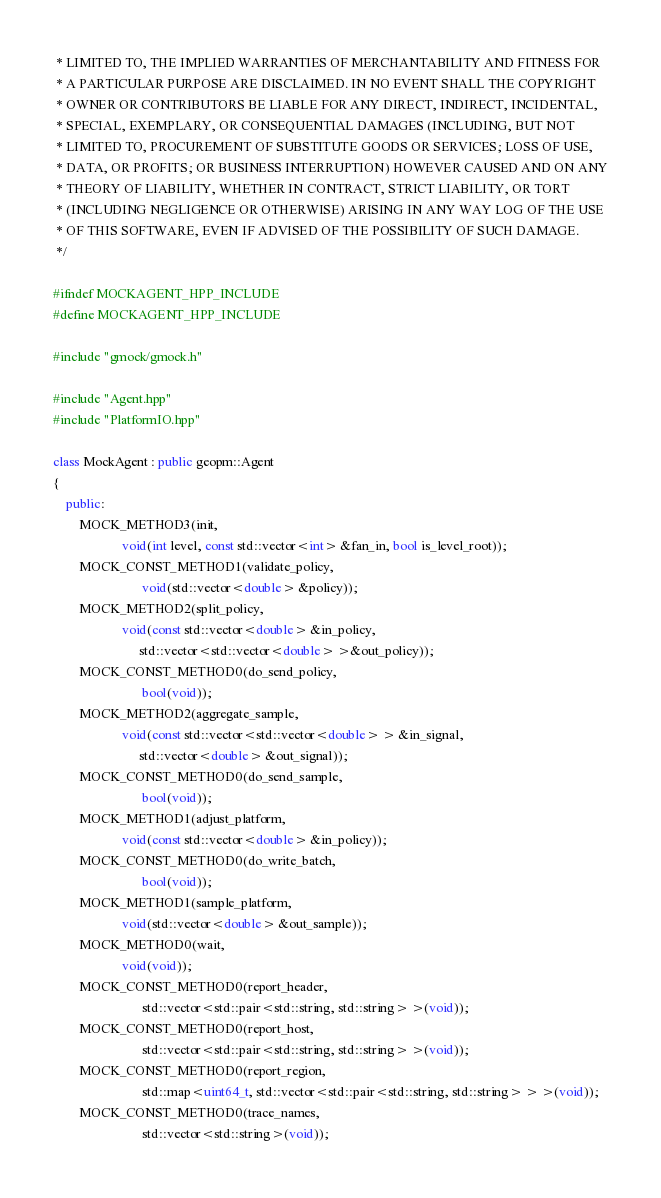Convert code to text. <code><loc_0><loc_0><loc_500><loc_500><_C++_> * LIMITED TO, THE IMPLIED WARRANTIES OF MERCHANTABILITY AND FITNESS FOR
 * A PARTICULAR PURPOSE ARE DISCLAIMED. IN NO EVENT SHALL THE COPYRIGHT
 * OWNER OR CONTRIBUTORS BE LIABLE FOR ANY DIRECT, INDIRECT, INCIDENTAL,
 * SPECIAL, EXEMPLARY, OR CONSEQUENTIAL DAMAGES (INCLUDING, BUT NOT
 * LIMITED TO, PROCUREMENT OF SUBSTITUTE GOODS OR SERVICES; LOSS OF USE,
 * DATA, OR PROFITS; OR BUSINESS INTERRUPTION) HOWEVER CAUSED AND ON ANY
 * THEORY OF LIABILITY, WHETHER IN CONTRACT, STRICT LIABILITY, OR TORT
 * (INCLUDING NEGLIGENCE OR OTHERWISE) ARISING IN ANY WAY LOG OF THE USE
 * OF THIS SOFTWARE, EVEN IF ADVISED OF THE POSSIBILITY OF SUCH DAMAGE.
 */

#ifndef MOCKAGENT_HPP_INCLUDE
#define MOCKAGENT_HPP_INCLUDE

#include "gmock/gmock.h"

#include "Agent.hpp"
#include "PlatformIO.hpp"

class MockAgent : public geopm::Agent
{
    public:
        MOCK_METHOD3(init,
                     void(int level, const std::vector<int> &fan_in, bool is_level_root));
        MOCK_CONST_METHOD1(validate_policy,
                           void(std::vector<double> &policy));
        MOCK_METHOD2(split_policy,
                     void(const std::vector<double> &in_policy,
                          std::vector<std::vector<double> >&out_policy));
        MOCK_CONST_METHOD0(do_send_policy,
                           bool(void));
        MOCK_METHOD2(aggregate_sample,
                     void(const std::vector<std::vector<double> > &in_signal,
                          std::vector<double> &out_signal));
        MOCK_CONST_METHOD0(do_send_sample,
                           bool(void));
        MOCK_METHOD1(adjust_platform,
                     void(const std::vector<double> &in_policy));
        MOCK_CONST_METHOD0(do_write_batch,
                           bool(void));
        MOCK_METHOD1(sample_platform,
                     void(std::vector<double> &out_sample));
        MOCK_METHOD0(wait,
                     void(void));
        MOCK_CONST_METHOD0(report_header,
                           std::vector<std::pair<std::string, std::string> >(void));
        MOCK_CONST_METHOD0(report_host,
                           std::vector<std::pair<std::string, std::string> >(void));
        MOCK_CONST_METHOD0(report_region,
                           std::map<uint64_t, std::vector<std::pair<std::string, std::string> > >(void));
        MOCK_CONST_METHOD0(trace_names,
                           std::vector<std::string>(void));</code> 